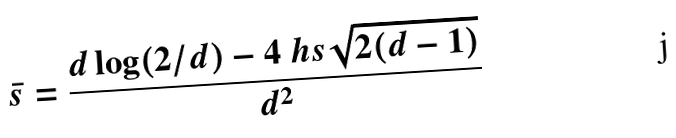Convert formula to latex. <formula><loc_0><loc_0><loc_500><loc_500>\bar { s } = \frac { d \log ( 2 / d ) - 4 \ h s \sqrt { 2 ( d - 1 ) } } { d ^ { 2 } }</formula> 